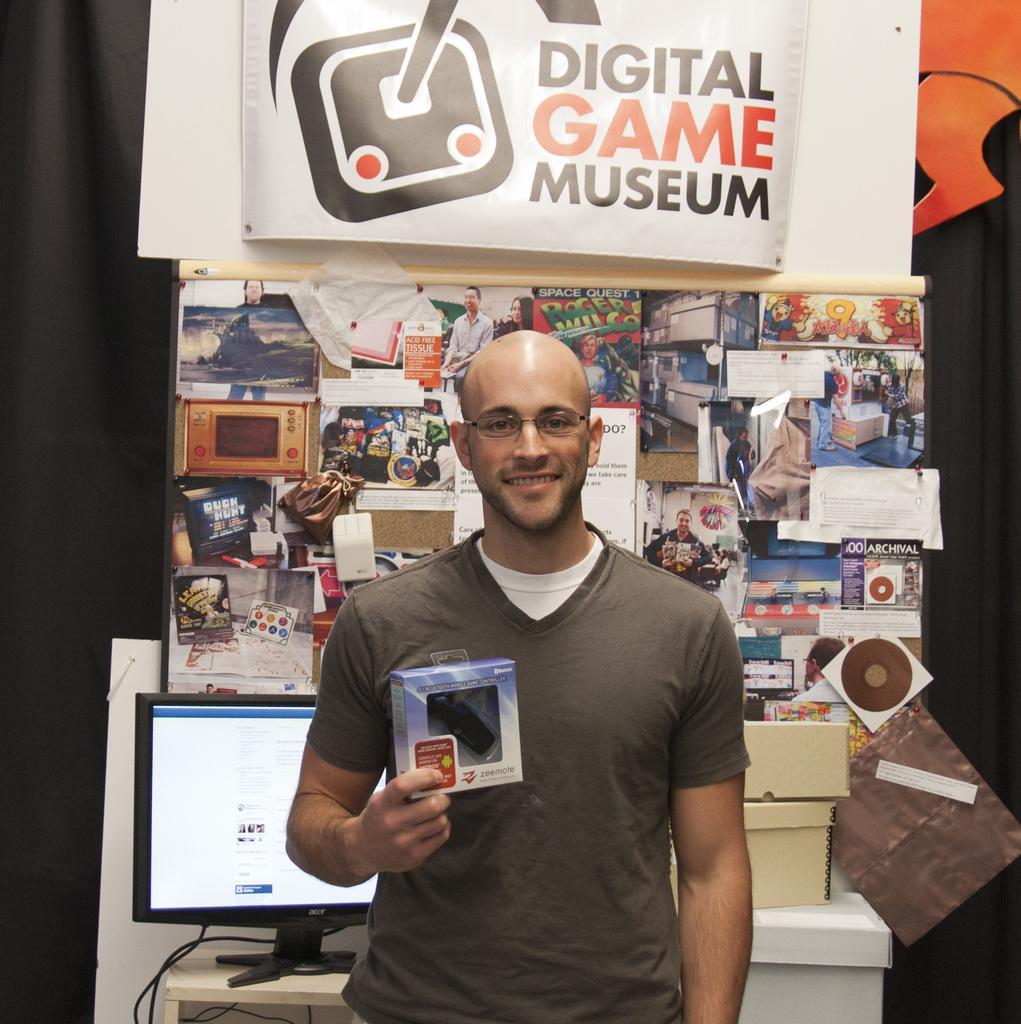Please provide a concise description of this image. In this image I can see the person standing and holding the cardboard box and the person is wearing brown color dress. Background I can see the system and I can also see few posts attached to the board and I can see the banner in white color. 